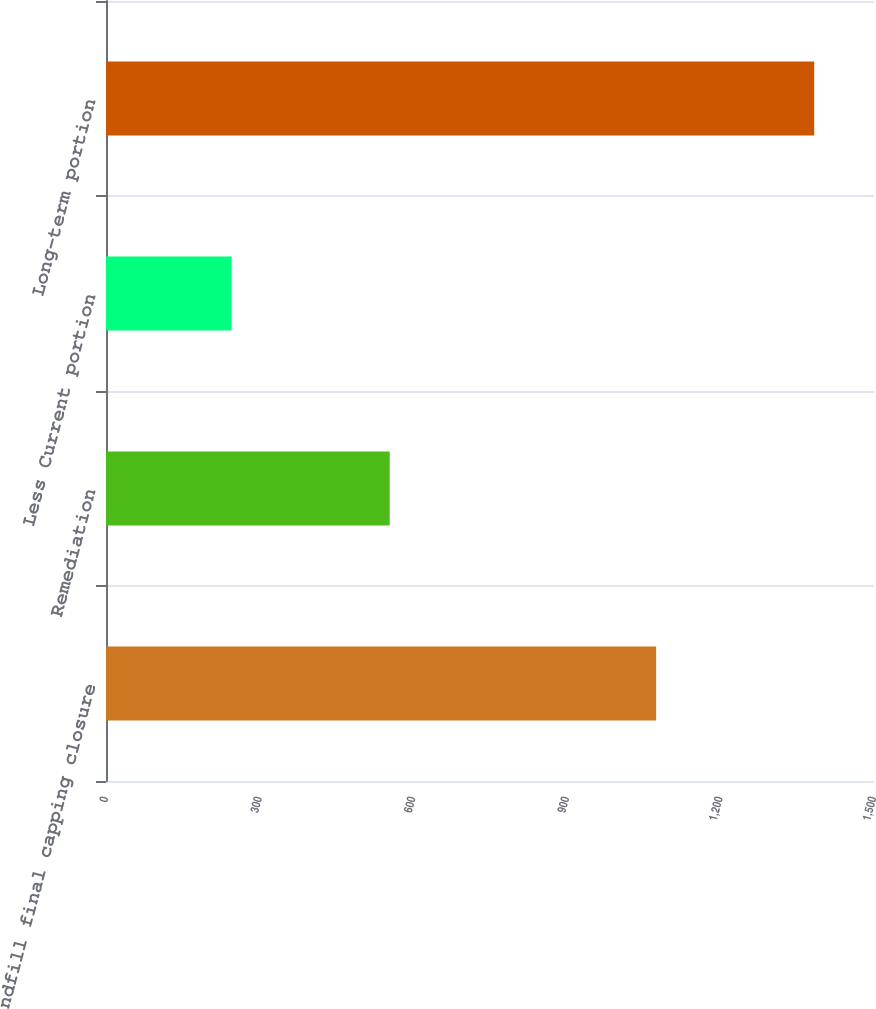Convert chart. <chart><loc_0><loc_0><loc_500><loc_500><bar_chart><fcel>Landfill final capping closure<fcel>Remediation<fcel>Less Current portion<fcel>Long-term portion<nl><fcel>1074.5<fcel>554.1<fcel>245.4<fcel>1383.2<nl></chart> 